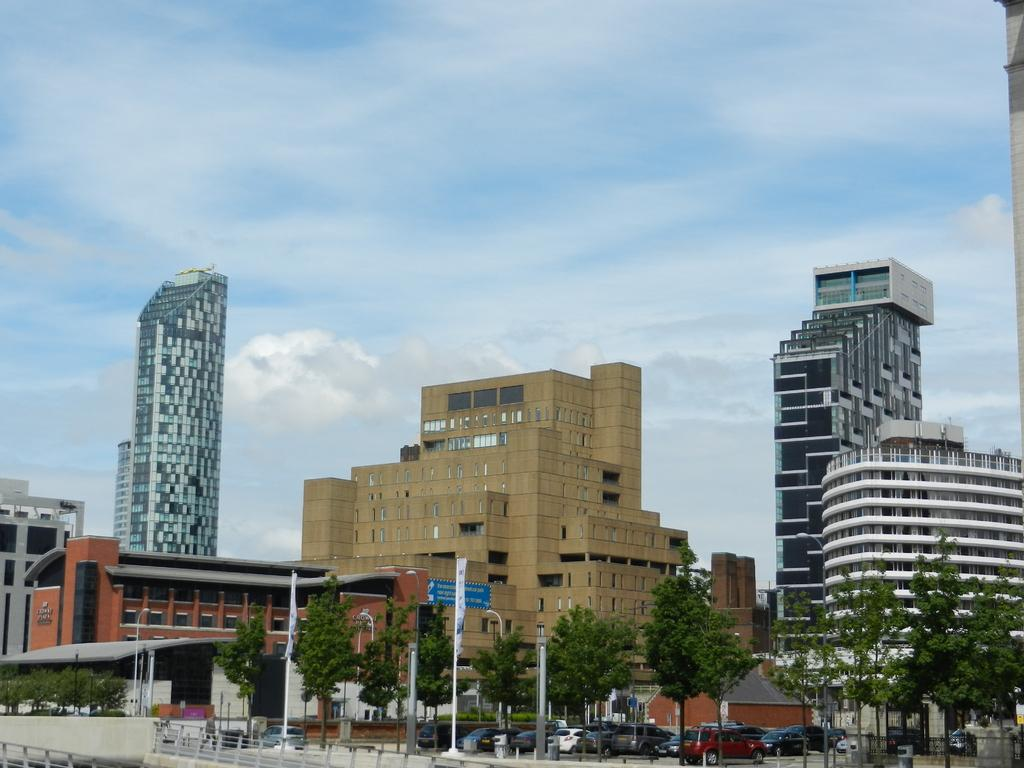What type of vehicles can be seen in the front of the image? There are cars in the front of the image. What type of natural elements are present on either side of the road in the image? Trees are present on either side of the road in the image. What type of structures can be seen in the background of the image? There are buildings in the background of the image. What part of the natural environment is visible in the image? The sky is visible in the image. What type of weather can be inferred from the presence of clouds in the sky? Clouds are present in the sky, which suggests that the weather might be partly cloudy or overcast. What type of songs can be heard coming from the buildings in the image? There is no indication in the image that any songs are being played or heard from the buildings. What type of attraction is present in the image? The image does not depict any specific attractions; it shows cars, trees, buildings, and the sky. 